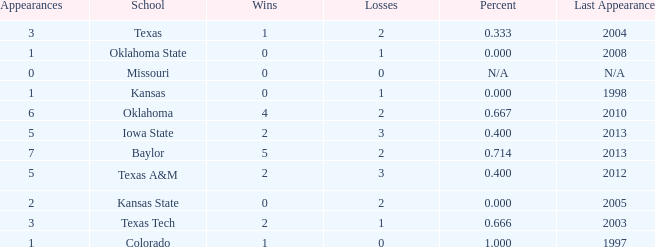How many wins did Baylor have?  1.0. 